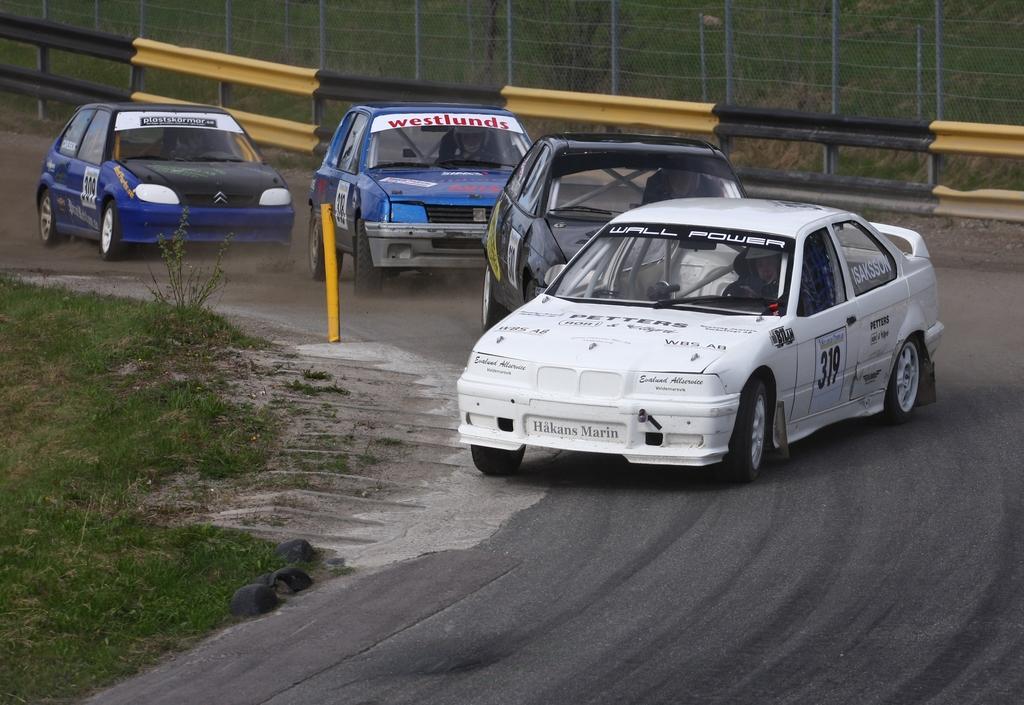In one or two sentences, can you explain what this image depicts? In the middle of the image there are some vehicles on the road. Behind the vehicle there is fencing. Behind the fencing there are some trees. In the bottom left corner of the image there is grass. 